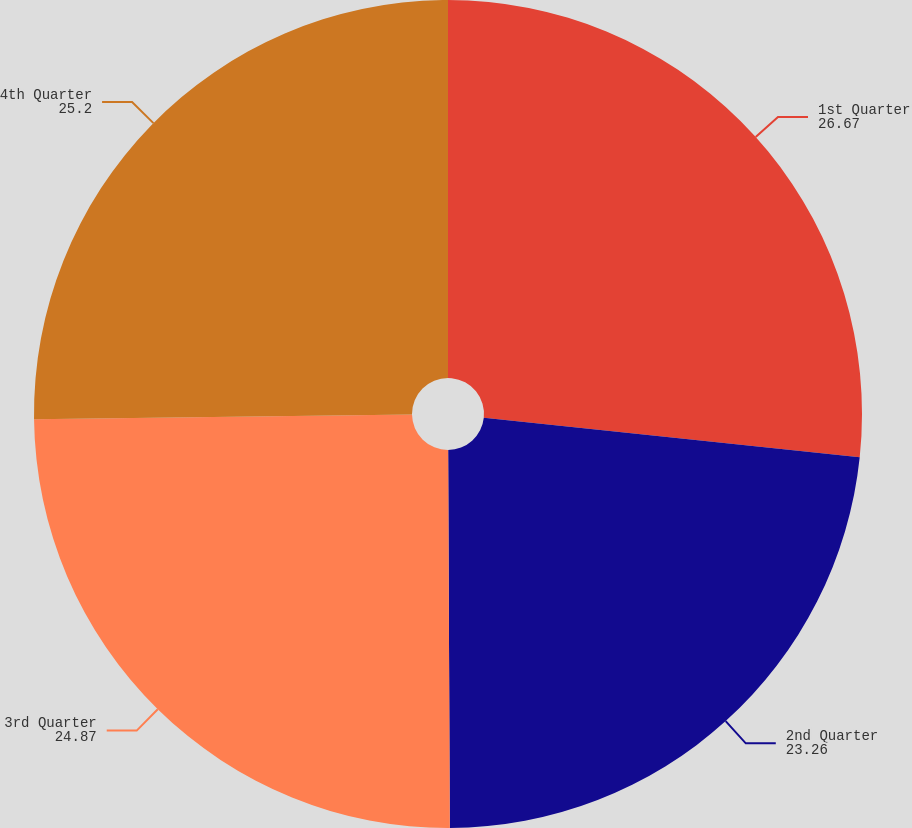Convert chart to OTSL. <chart><loc_0><loc_0><loc_500><loc_500><pie_chart><fcel>1st Quarter<fcel>2nd Quarter<fcel>3rd Quarter<fcel>4th Quarter<nl><fcel>26.67%<fcel>23.26%<fcel>24.87%<fcel>25.2%<nl></chart> 